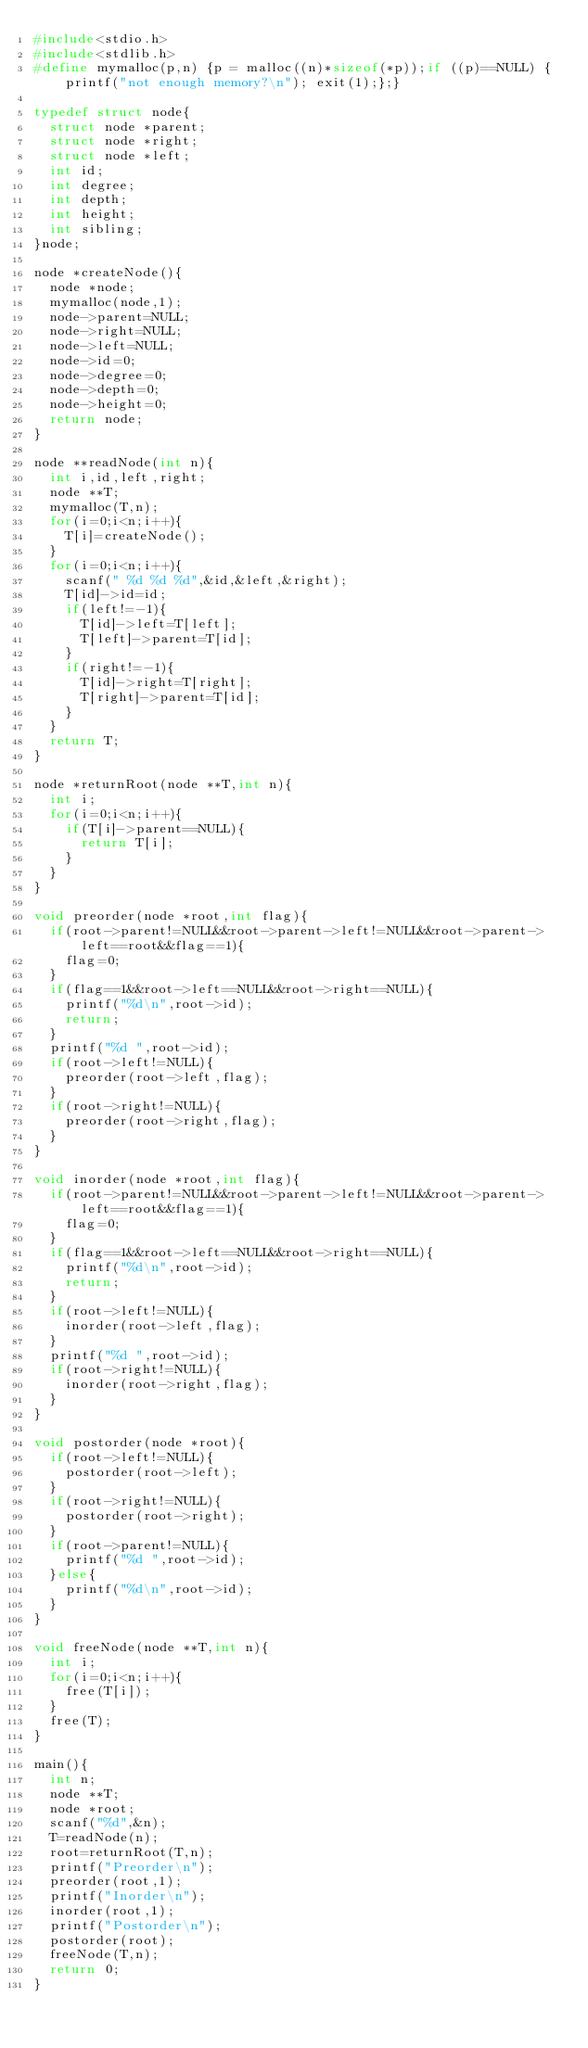<code> <loc_0><loc_0><loc_500><loc_500><_C_>#include<stdio.h>
#include<stdlib.h>
#define mymalloc(p,n) {p = malloc((n)*sizeof(*p));if ((p)==NULL) {printf("not enough memory?\n"); exit(1);};}

typedef struct node{
	struct node *parent;
	struct node *right;
	struct node *left;
	int id;
	int degree;
	int depth;
	int height;
	int sibling;
}node;

node *createNode(){
	node *node;
	mymalloc(node,1);
	node->parent=NULL;
	node->right=NULL;
	node->left=NULL;
	node->id=0;
	node->degree=0;
	node->depth=0;
	node->height=0;
	return node;
}

node **readNode(int n){
	int i,id,left,right;
	node **T;
	mymalloc(T,n);
	for(i=0;i<n;i++){
		T[i]=createNode();
	}
	for(i=0;i<n;i++){
		scanf(" %d %d %d",&id,&left,&right);
		T[id]->id=id;
		if(left!=-1){
			T[id]->left=T[left];
			T[left]->parent=T[id];
		}
		if(right!=-1){
			T[id]->right=T[right];
			T[right]->parent=T[id];
		}
	}
	return T;
}

node *returnRoot(node **T,int n){
	int i;
	for(i=0;i<n;i++){
		if(T[i]->parent==NULL){
			return T[i];
		}
	}
}

void preorder(node *root,int flag){
	if(root->parent!=NULL&&root->parent->left!=NULL&&root->parent->left==root&&flag==1){
		flag=0;
	}
	if(flag==1&&root->left==NULL&&root->right==NULL){
		printf("%d\n",root->id);
		return;
	}
	printf("%d ",root->id);
	if(root->left!=NULL){
		preorder(root->left,flag);
	}
	if(root->right!=NULL){
		preorder(root->right,flag);
	}
}

void inorder(node *root,int flag){
	if(root->parent!=NULL&&root->parent->left!=NULL&&root->parent->left==root&&flag==1){
		flag=0;
	}
	if(flag==1&&root->left==NULL&&root->right==NULL){
		printf("%d\n",root->id);
		return;
	}
	if(root->left!=NULL){
		inorder(root->left,flag);
	}
	printf("%d ",root->id);
	if(root->right!=NULL){
		inorder(root->right,flag);
	}
}

void postorder(node *root){
	if(root->left!=NULL){
		postorder(root->left);
	}
	if(root->right!=NULL){
		postorder(root->right);
	}
	if(root->parent!=NULL){
		printf("%d ",root->id);
	}else{
		printf("%d\n",root->id);
	}
}

void freeNode(node **T,int n){
	int i;
	for(i=0;i<n;i++){
		free(T[i]);
	}
	free(T);
}

main(){
	int n;
	node **T;
	node *root;
	scanf("%d",&n);
	T=readNode(n);
	root=returnRoot(T,n);
	printf("Preorder\n");
	preorder(root,1);
	printf("Inorder\n");
	inorder(root,1);
	printf("Postorder\n");
	postorder(root);
	freeNode(T,n);
	return 0;
}</code> 